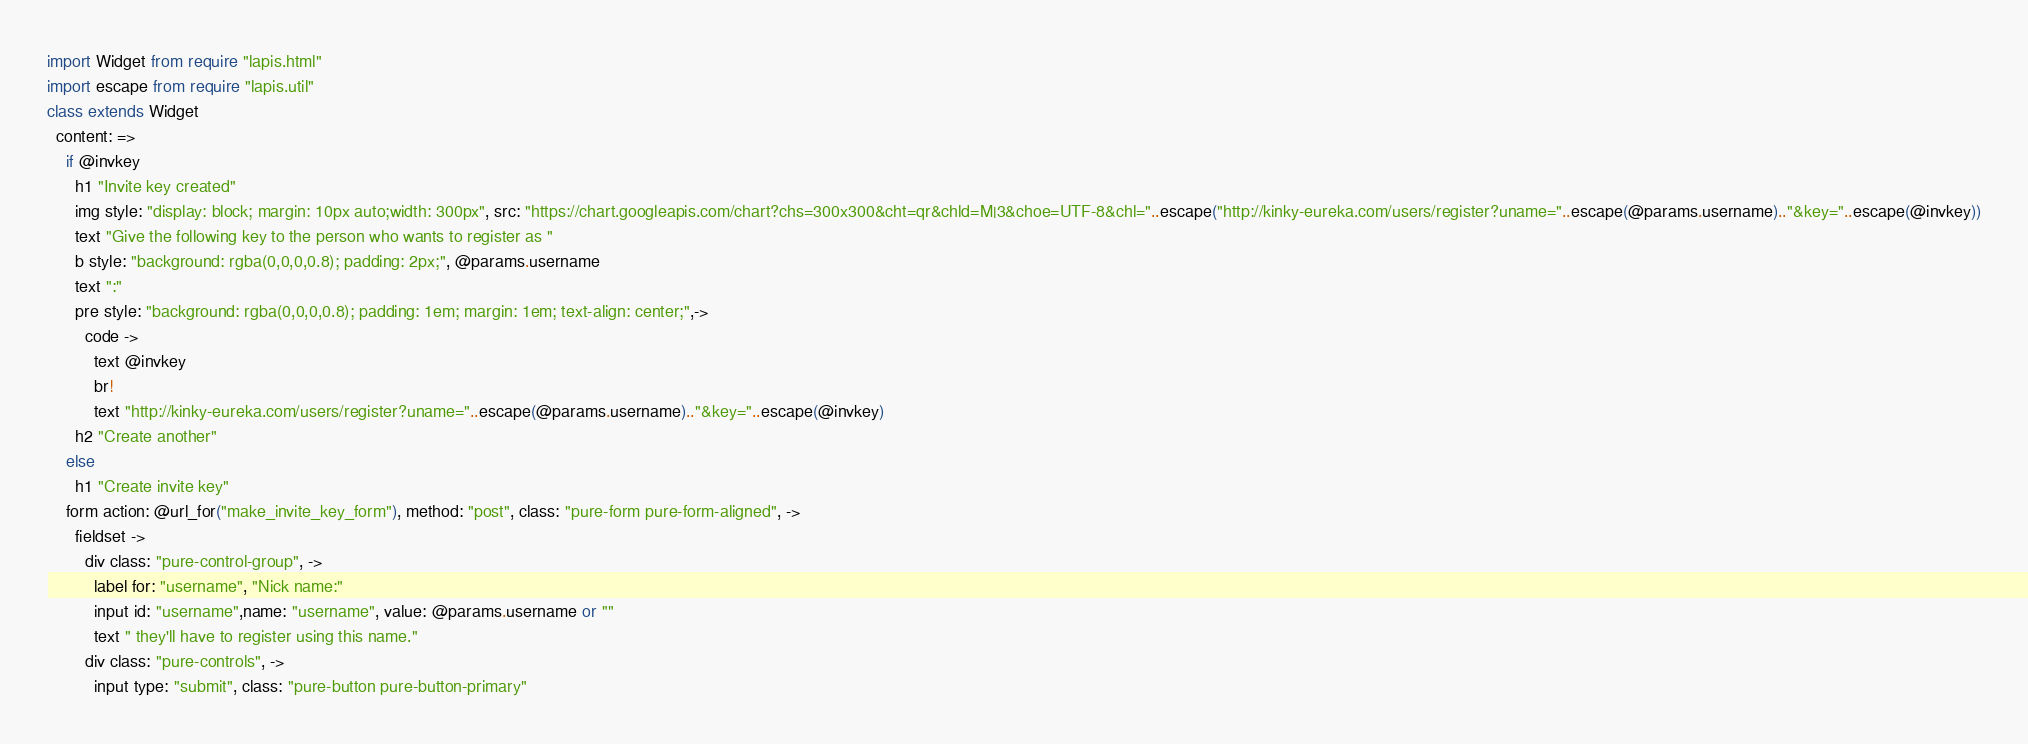Convert code to text. <code><loc_0><loc_0><loc_500><loc_500><_MoonScript_>import Widget from require "lapis.html"
import escape from require "lapis.util"
class extends Widget
  content: =>
    if @invkey
      h1 "Invite key created"
      img style: "display: block; margin: 10px auto;width: 300px", src: "https://chart.googleapis.com/chart?chs=300x300&cht=qr&chld=M|3&choe=UTF-8&chl="..escape("http://kinky-eureka.com/users/register?uname="..escape(@params.username).."&key="..escape(@invkey))
      text "Give the following key to the person who wants to register as "
      b style: "background: rgba(0,0,0,0.8); padding: 2px;", @params.username
      text ":"
      pre style: "background: rgba(0,0,0,0.8); padding: 1em; margin: 1em; text-align: center;",->
        code ->
          text @invkey
          br!
          text "http://kinky-eureka.com/users/register?uname="..escape(@params.username).."&key="..escape(@invkey)
      h2 "Create another"
    else
      h1 "Create invite key"
    form action: @url_for("make_invite_key_form"), method: "post", class: "pure-form pure-form-aligned", ->
      fieldset ->
        div class: "pure-control-group", ->
          label for: "username", "Nick name:"
          input id: "username",name: "username", value: @params.username or ""
          text " they'll have to register using this name."
        div class: "pure-controls", ->
          input type: "submit", class: "pure-button pure-button-primary"
</code> 